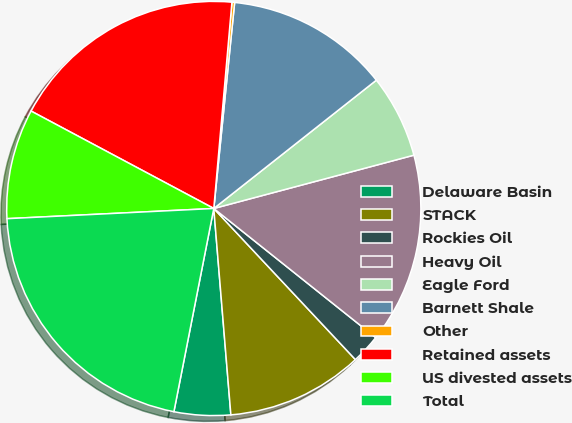<chart> <loc_0><loc_0><loc_500><loc_500><pie_chart><fcel>Delaware Basin<fcel>STACK<fcel>Rockies Oil<fcel>Heavy Oil<fcel>Eagle Ford<fcel>Barnett Shale<fcel>Other<fcel>Retained assets<fcel>US divested assets<fcel>Total<nl><fcel>4.4%<fcel>10.67%<fcel>2.3%<fcel>14.86%<fcel>6.49%<fcel>12.76%<fcel>0.21%<fcel>18.6%<fcel>8.58%<fcel>21.13%<nl></chart> 